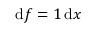<formula> <loc_0><loc_0><loc_500><loc_500>{ d } f = 1 \, { d } x</formula> 